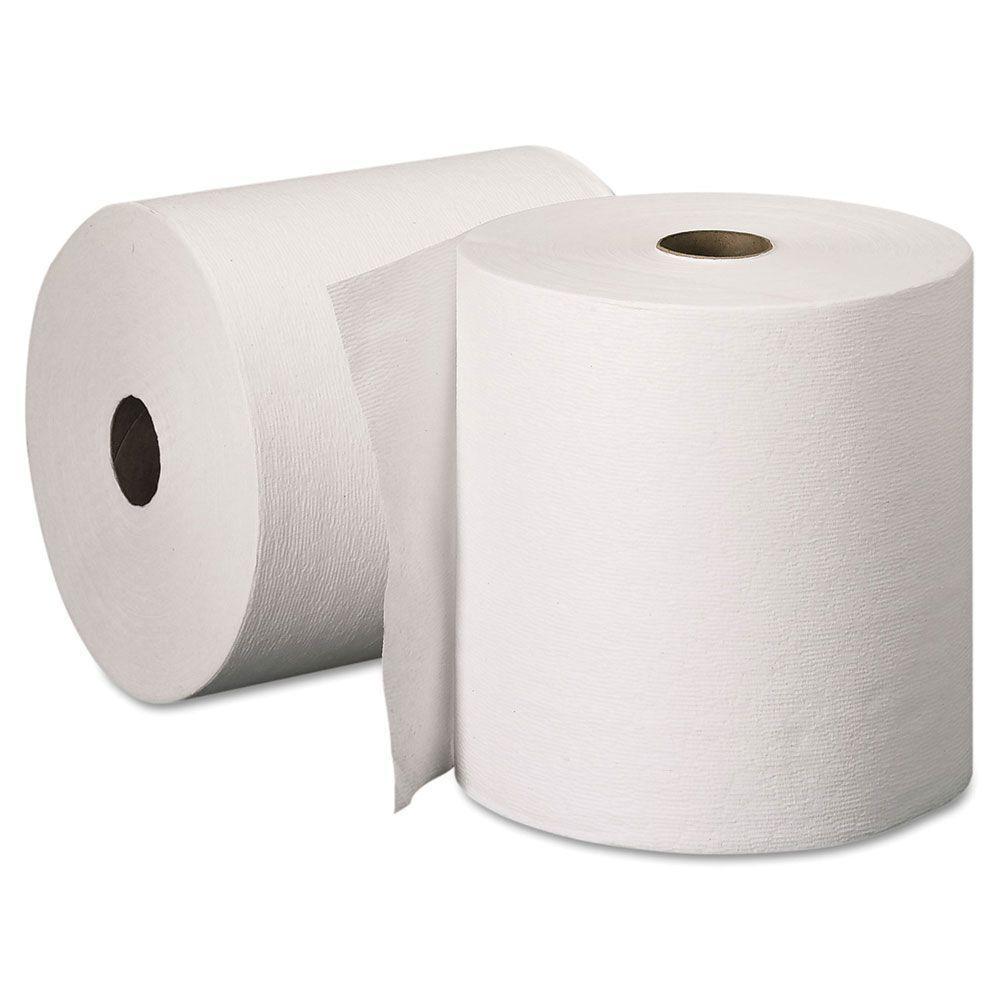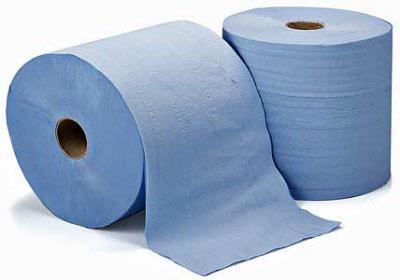The first image is the image on the left, the second image is the image on the right. Analyze the images presented: Is the assertion "At least 1 roll is standing vertically." valid? Answer yes or no. Yes. 